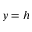<formula> <loc_0><loc_0><loc_500><loc_500>y = h</formula> 